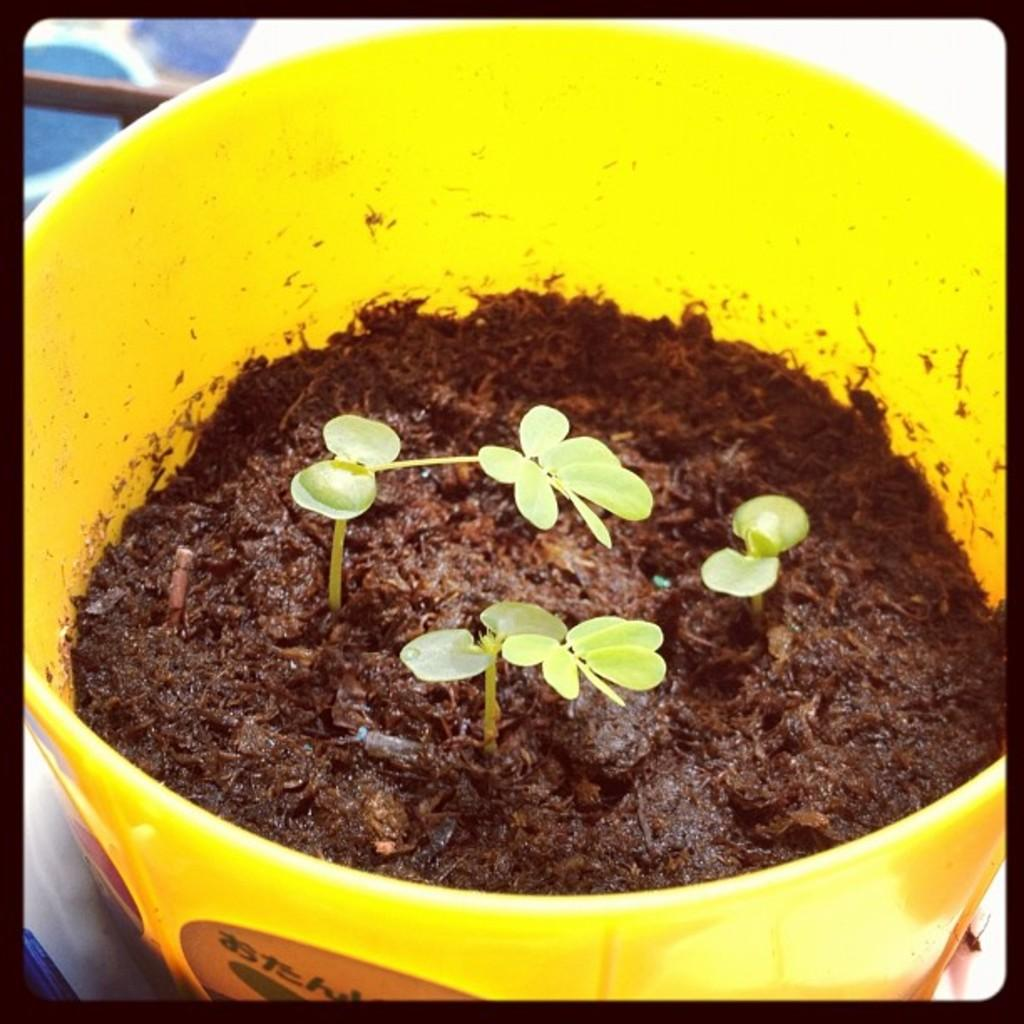What type of plants can be seen in the image? There are small plants in the image. How are the small plants arranged or contained in the image? The small plants are kept in a bowl. What type of education is being provided to the plants in the image? There is no indication in the image that the plants are receiving any education. 